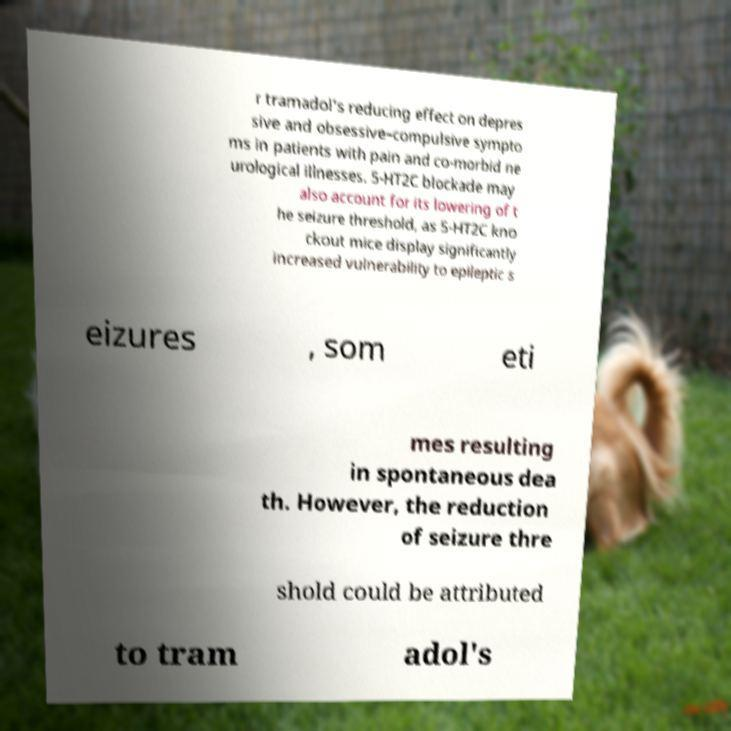Can you accurately transcribe the text from the provided image for me? r tramadol's reducing effect on depres sive and obsessive–compulsive sympto ms in patients with pain and co-morbid ne urological illnesses. 5-HT2C blockade may also account for its lowering of t he seizure threshold, as 5-HT2C kno ckout mice display significantly increased vulnerability to epileptic s eizures , som eti mes resulting in spontaneous dea th. However, the reduction of seizure thre shold could be attributed to tram adol's 